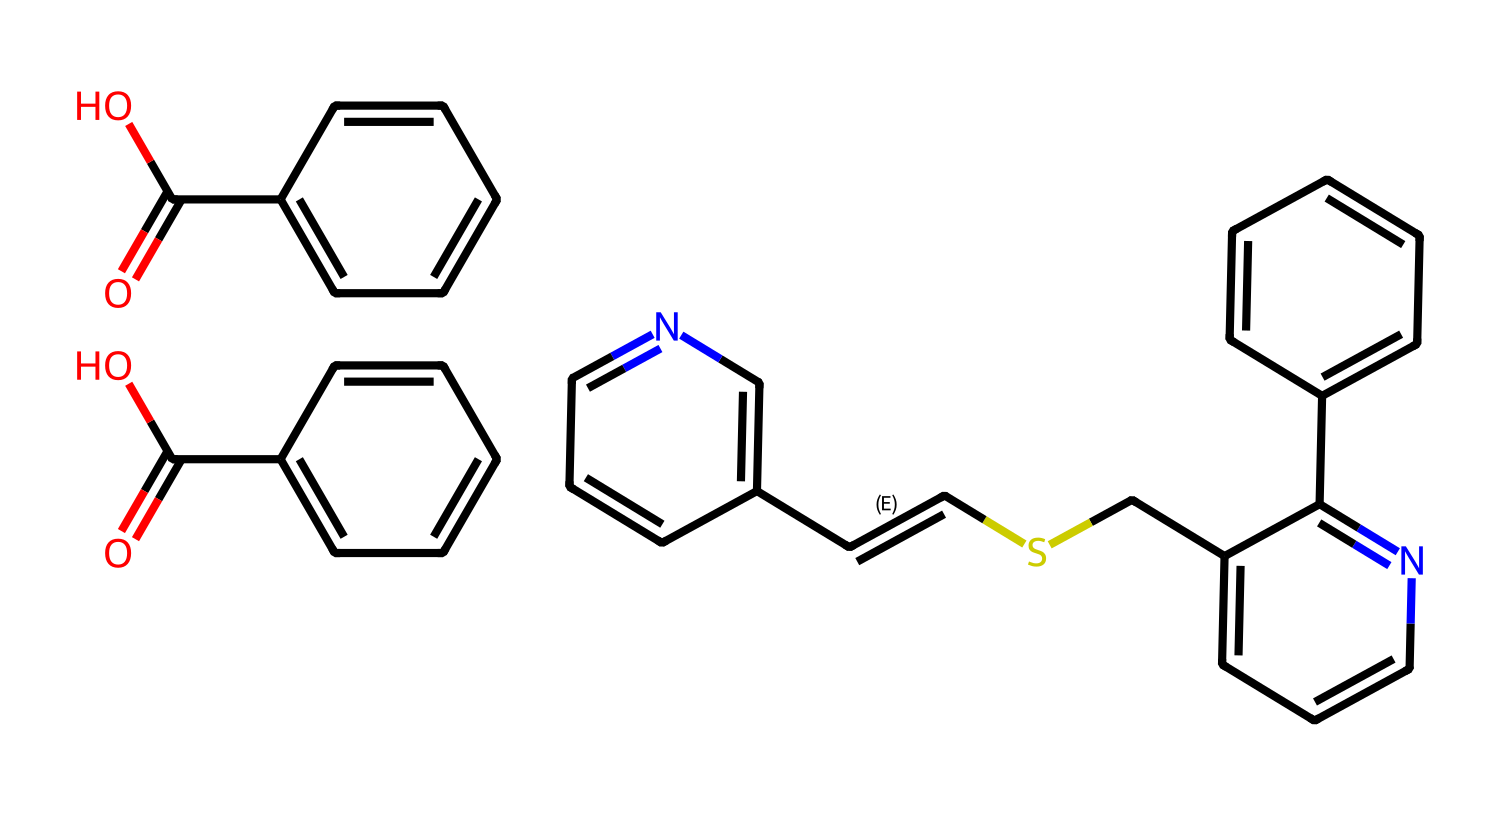What is the molecular formula of pyrantel pamoate? To find the molecular formula, we need to count the number of each type of atom based on the SMILES representation. We have carbon (C), hydrogen (H), nitrogen (N), and oxygen (O) atoms. The molecular formula can be derived from counting these atoms in the whole structure.
Answer: C22H30N2O4 How many rings are present in the molecular structure? By analyzing the chemical structure derived from the SMILES, I can identify the presence of cyclic structures. Each cyclic arrangement contributes to the total count of rings. The structure reveals three distinct benzene rings, hence the total is three rings.
Answer: 3 What functional groups are present in pyrantel pamoate? Functional groups can be determined by looking for specific arrangements of atoms that indicate certain chemical reactivity. In this molecule, carboxylic acid (from the C(=O)O structure) and an aromatic amine (due to the carbon-nitrogen bonds) can be observed.
Answer: carboxylic acid and aromatic amine What is the significance of the nitrogen atoms in the structure? The presence of nitrogen atoms indicates that pyrantel pamoate is an anthelmintic agent, as nitrogen is a characteristic feature of many deworming medications. The nitrogen allows for interaction with parasitic organisms.
Answer: anthelmintic agent How many total carbon atoms are in pyrantel pamoate? By carefully examining the SMILES notation and counting each carbon atom associated with the structure, we can determine that there are 22 carbon atoms.
Answer: 22 What type of chemical is pyrantel pamoate classified as? Pyrantel pamoate is categorized based on its use and chemical properties; specifically, it is classified as a broad-spectrum anthelmintic agent used for deworming. Its characteristics and applications indicate its classification.
Answer: anthelmintic agent 